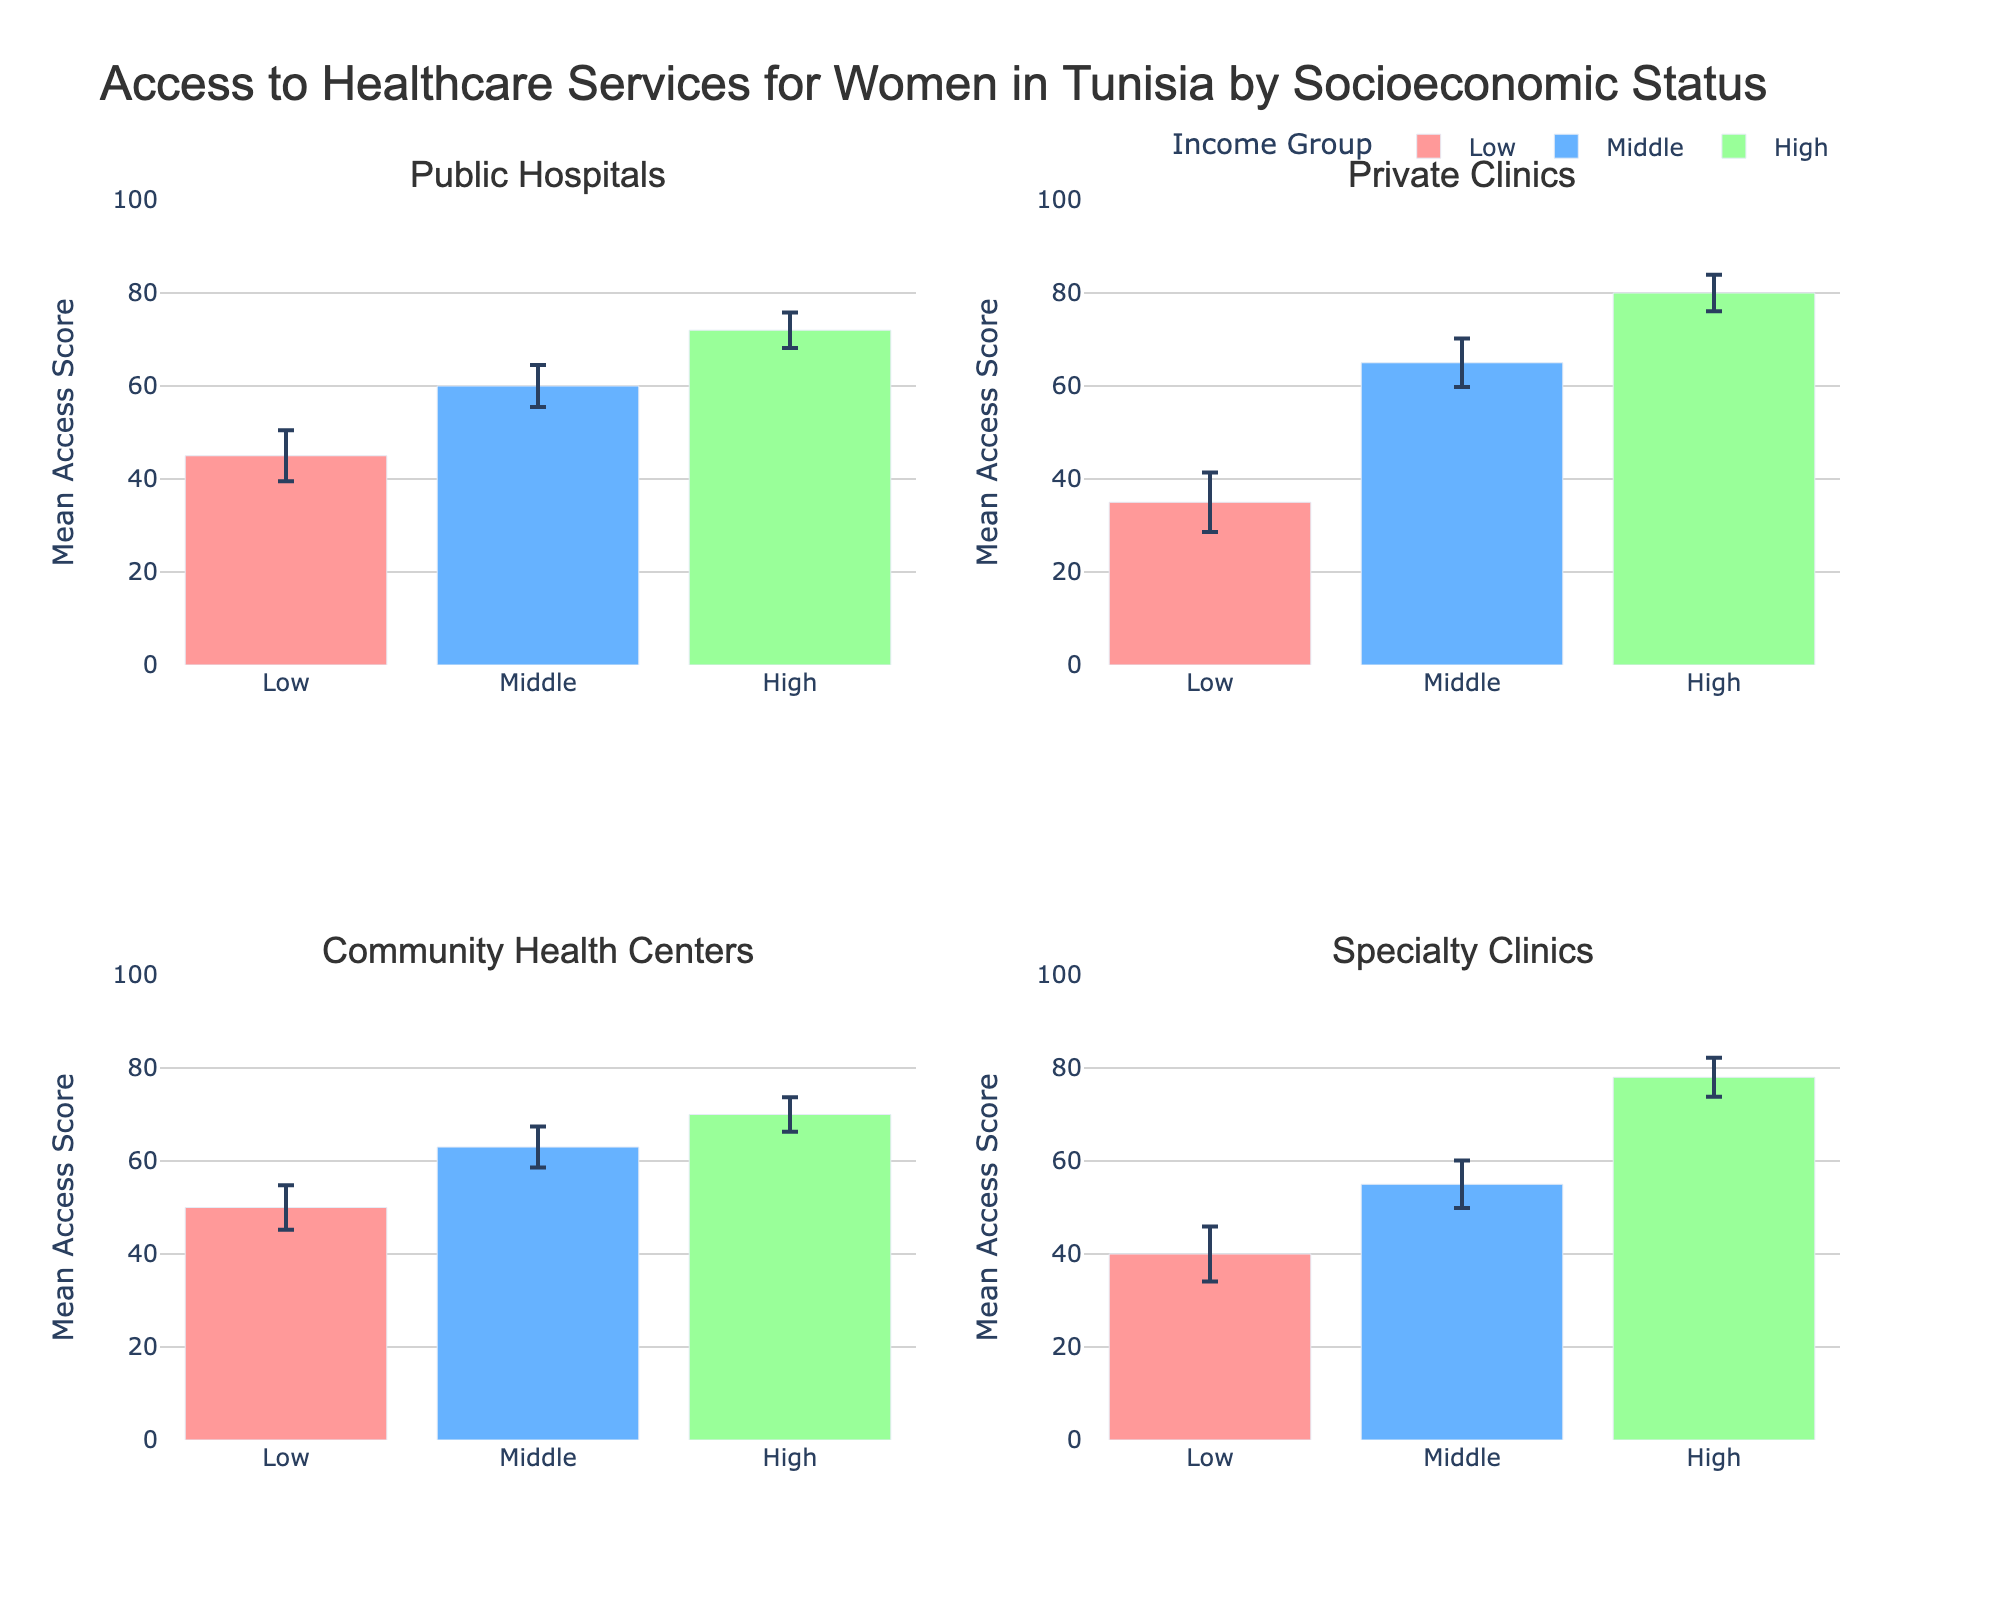What is the title of the figure? The title of the figure is located at the top and clearly indicates the main focus of the data.
Answer: Access to Healthcare Services for Women in Tunisia by Socioeconomic Status Which facility has the highest mean access score for the low-income group? To determine this, look at the mean access scores for the low-income group across all subplots and identify the highest value.
Answer: Community Health Centers What is the range of mean access scores across all facilities for the middle-income group? First, find the mean access scores for the middle-income group in all subplots. Then, calculate the difference between the highest and lowest scores. Community Health Centers (63) - Specialty Clinics (55) = 8.
Answer: 8 How do the mean access scores compare between private clinics and public hospitals for the high-income group? Compare the mean access scores given for private clinics and public hospitals within the high-income group subplot by subplot. Private Clinics: 80, Public Hospitals: 72
Answer: Private Clinics have a higher score Which income group shows the largest variance in mean access scores within public hospitals? Identify each income group's error bar (standard deviation) within the public hospitals' subplot and compare the sizes. The low-income group has the largest error bar.
Answer: Low-income group For low-income women, which type of healthcare facility has the lowest mean access score? Find and compare the mean access score bars for the low-income group in each subplot to identify the lowest score.
Answer: Private Clinics What is the mean access score difference between public hospitals and specialty clinics for the middle-income group? Look at the mean access scores for middle-income in both public hospitals and specialty clinics and calculate the difference: 60 (Public Hospitals) - 55 (Specialty Clinics) = 5
Answer: 5 If we consider the error bars, do the access scores for high-income women in private clinics and specialty clinics overlap? Compare the error bars in the high-income group between private clinics and specialty clinics subplots. If they overlap when considering the standard deviations, then they do overlap. Here, 80±3.9 and 78±4.2 do overlap.
Answer: Yes Which healthcare facility has the least variance in mean access scores for the middle-income group? Compare the size of the error bars for the middle-income group in each facility's subplot to determine the smallest variance. Community Health Centers have the smallest error bar.
Answer: Community Health Centers What is the overall trend observed in access to healthcare services as we go from low to high-income groups across all facilities? Observe the trend lines and the heights of the bars for low, middle, and high-income groups within each subplot. Generally, the access scores improve with the increase in income across all healthcare facilities.
Answer: Increase 